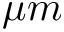Convert formula to latex. <formula><loc_0><loc_0><loc_500><loc_500>{ \mu m }</formula> 